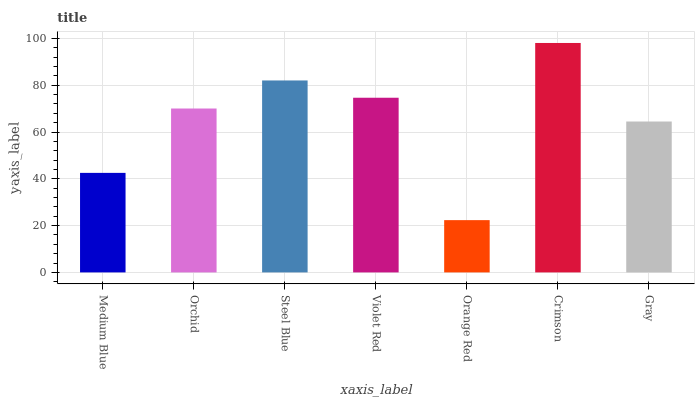Is Orange Red the minimum?
Answer yes or no. Yes. Is Crimson the maximum?
Answer yes or no. Yes. Is Orchid the minimum?
Answer yes or no. No. Is Orchid the maximum?
Answer yes or no. No. Is Orchid greater than Medium Blue?
Answer yes or no. Yes. Is Medium Blue less than Orchid?
Answer yes or no. Yes. Is Medium Blue greater than Orchid?
Answer yes or no. No. Is Orchid less than Medium Blue?
Answer yes or no. No. Is Orchid the high median?
Answer yes or no. Yes. Is Orchid the low median?
Answer yes or no. Yes. Is Orange Red the high median?
Answer yes or no. No. Is Crimson the low median?
Answer yes or no. No. 